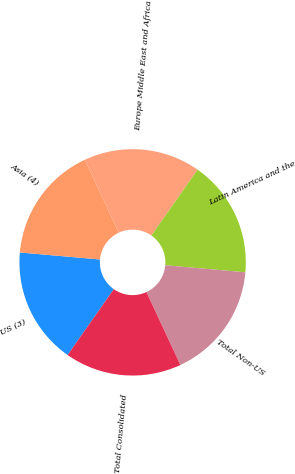Convert chart to OTSL. <chart><loc_0><loc_0><loc_500><loc_500><pie_chart><fcel>US (3)<fcel>Asia (4)<fcel>Europe Middle East and Africa<fcel>Latin America and the<fcel>Total Non-US<fcel>Total Consolidated<nl><fcel>16.66%<fcel>16.67%<fcel>16.67%<fcel>16.67%<fcel>16.67%<fcel>16.67%<nl></chart> 